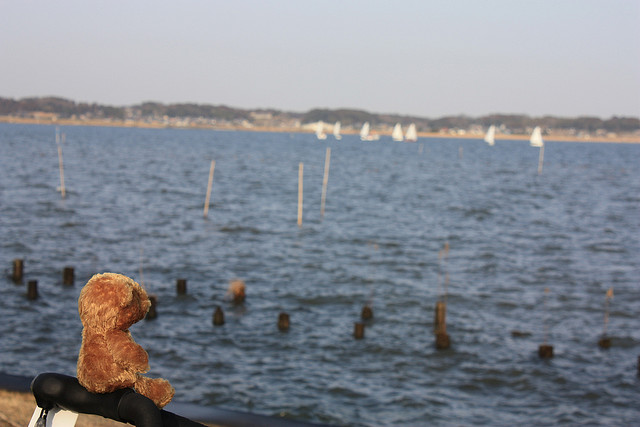<image>What animal is on the boat? There is no animal on the boat. However, it can be a bear or a dog. What animal is it? I don't know the exact animal. It can be a bear or a teddy bear. What animal is on the boat? I am not sure what animal is on the boat. It can be seen bear, dog or teddy bear. What animal is it? It is unclear what animal it is. It can be a bear or a teddy bear. 